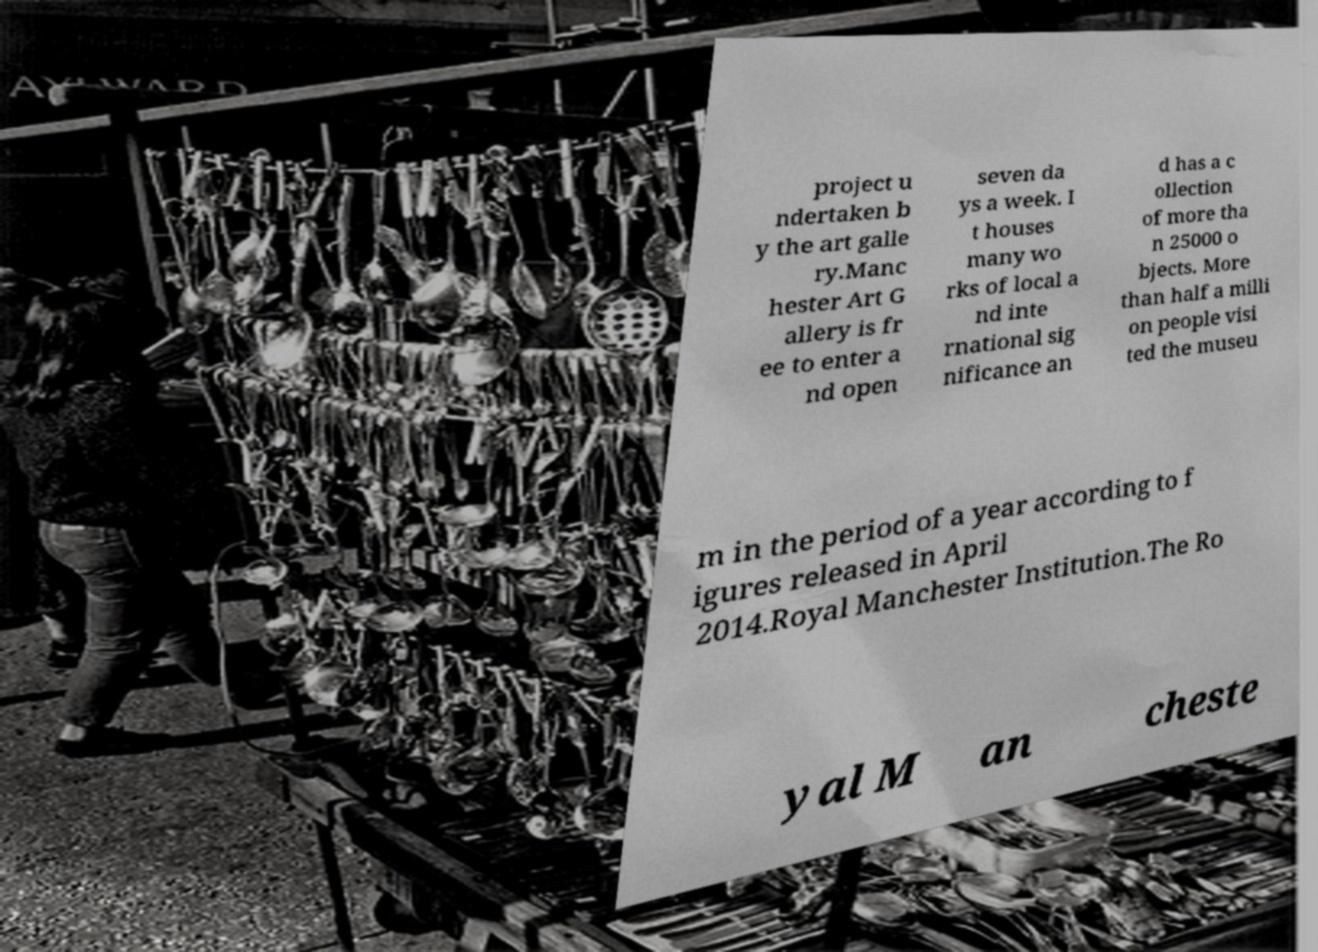Could you extract and type out the text from this image? project u ndertaken b y the art galle ry.Manc hester Art G allery is fr ee to enter a nd open seven da ys a week. I t houses many wo rks of local a nd inte rnational sig nificance an d has a c ollection of more tha n 25000 o bjects. More than half a milli on people visi ted the museu m in the period of a year according to f igures released in April 2014.Royal Manchester Institution.The Ro yal M an cheste 